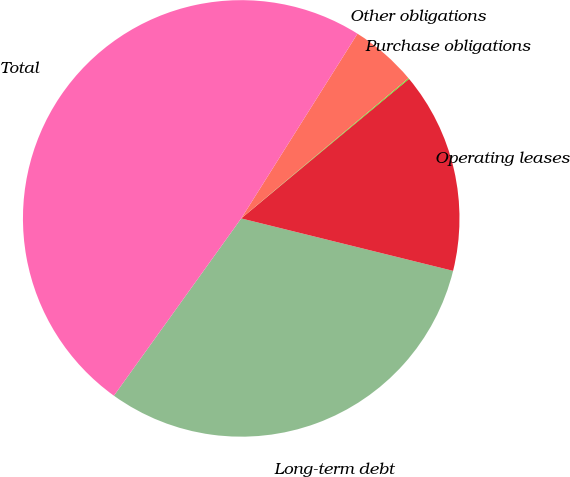Convert chart to OTSL. <chart><loc_0><loc_0><loc_500><loc_500><pie_chart><fcel>Long-term debt<fcel>Operating leases<fcel>Purchase obligations<fcel>Other obligations<fcel>Total<nl><fcel>31.05%<fcel>14.9%<fcel>0.06%<fcel>4.96%<fcel>49.03%<nl></chart> 